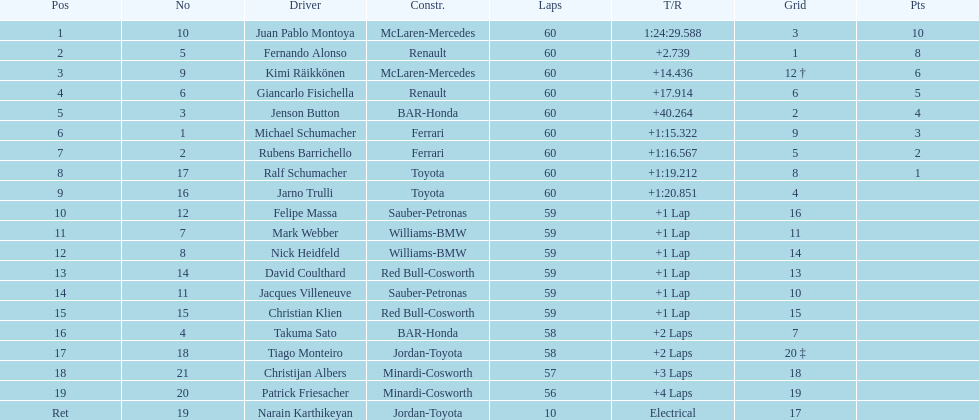After 8th position, how many points does a driver receive? 0. 